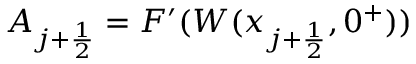<formula> <loc_0><loc_0><loc_500><loc_500>A _ { j + \frac { 1 } { 2 } } = F ^ { \prime } ( W ( x _ { j + \frac { 1 } { 2 } } , 0 ^ { + } ) )</formula> 